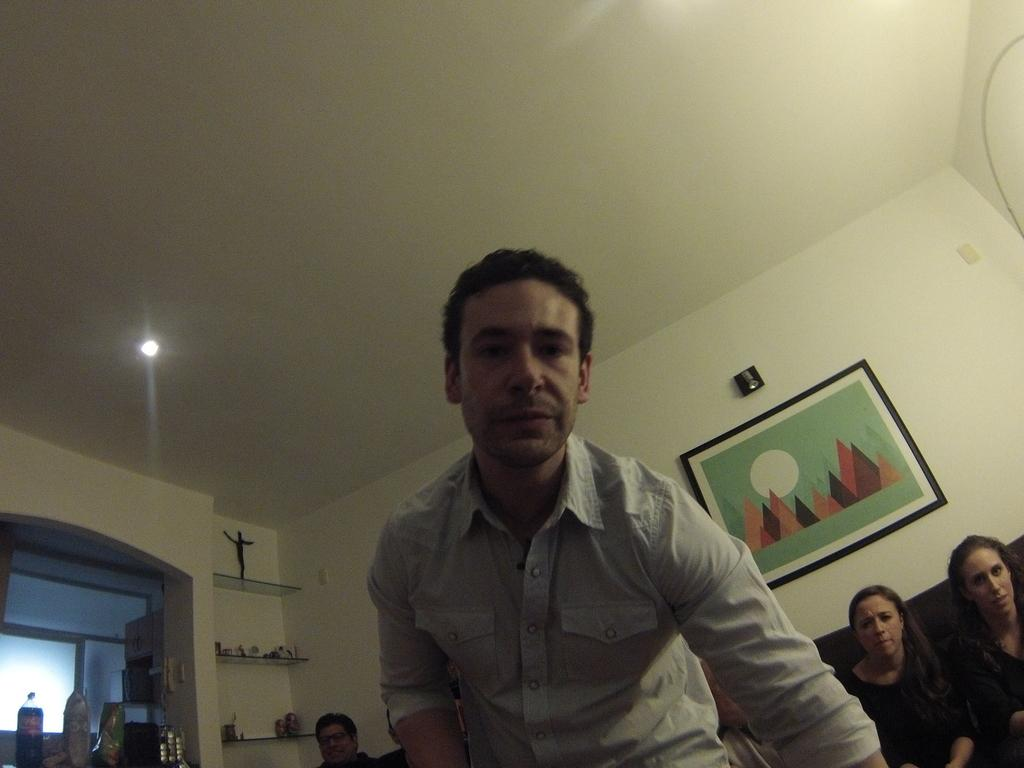What are the people in the image doing? The people in the image are seated. What is the man in the image doing? The man in the image is standing. What can be seen on the wall in the image? There is a photo frame on the wall. What type of lighting is present in the image? There is a roof light in the image. What objects are visible in the image that might contain liquid? There are bottles in the image. What type of objects are present in the image that might be used for play? There are toys in the image. What type of story is being told by the circle in the image? There is no circle present in the image, so no story can be told by it. How many fingers does the man have in the image? The number of fingers the man has cannot be determined from the image alone, as it does not show the man's hands. 